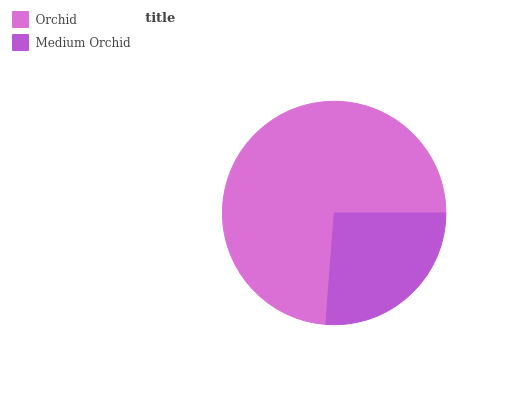Is Medium Orchid the minimum?
Answer yes or no. Yes. Is Orchid the maximum?
Answer yes or no. Yes. Is Medium Orchid the maximum?
Answer yes or no. No. Is Orchid greater than Medium Orchid?
Answer yes or no. Yes. Is Medium Orchid less than Orchid?
Answer yes or no. Yes. Is Medium Orchid greater than Orchid?
Answer yes or no. No. Is Orchid less than Medium Orchid?
Answer yes or no. No. Is Orchid the high median?
Answer yes or no. Yes. Is Medium Orchid the low median?
Answer yes or no. Yes. Is Medium Orchid the high median?
Answer yes or no. No. Is Orchid the low median?
Answer yes or no. No. 